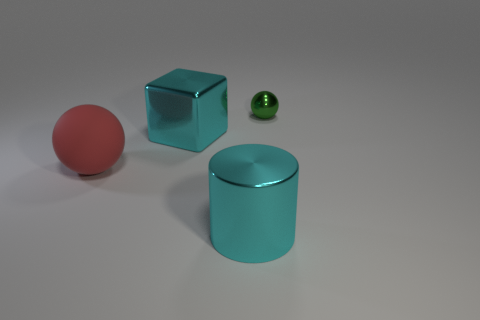There is a green thing that is the same shape as the red thing; what material is it?
Provide a succinct answer. Metal. How many cylinders are the same size as the matte sphere?
Provide a succinct answer. 1. The big cylinder that is the same material as the small green thing is what color?
Your response must be concise. Cyan. Are there fewer large cyan matte cylinders than small shiny things?
Provide a succinct answer. Yes. What number of green objects are large rubber cylinders or small metallic objects?
Provide a succinct answer. 1. What number of large cyan things are both in front of the big sphere and behind the red rubber ball?
Make the answer very short. 0. Do the cyan cube and the cylinder have the same material?
Keep it short and to the point. Yes. What shape is the cyan metallic thing that is the same size as the cyan block?
Give a very brief answer. Cylinder. Are there more big blue metallic things than big red balls?
Give a very brief answer. No. There is a big thing that is on the right side of the red rubber object and on the left side of the big cylinder; what is its material?
Offer a very short reply. Metal. 